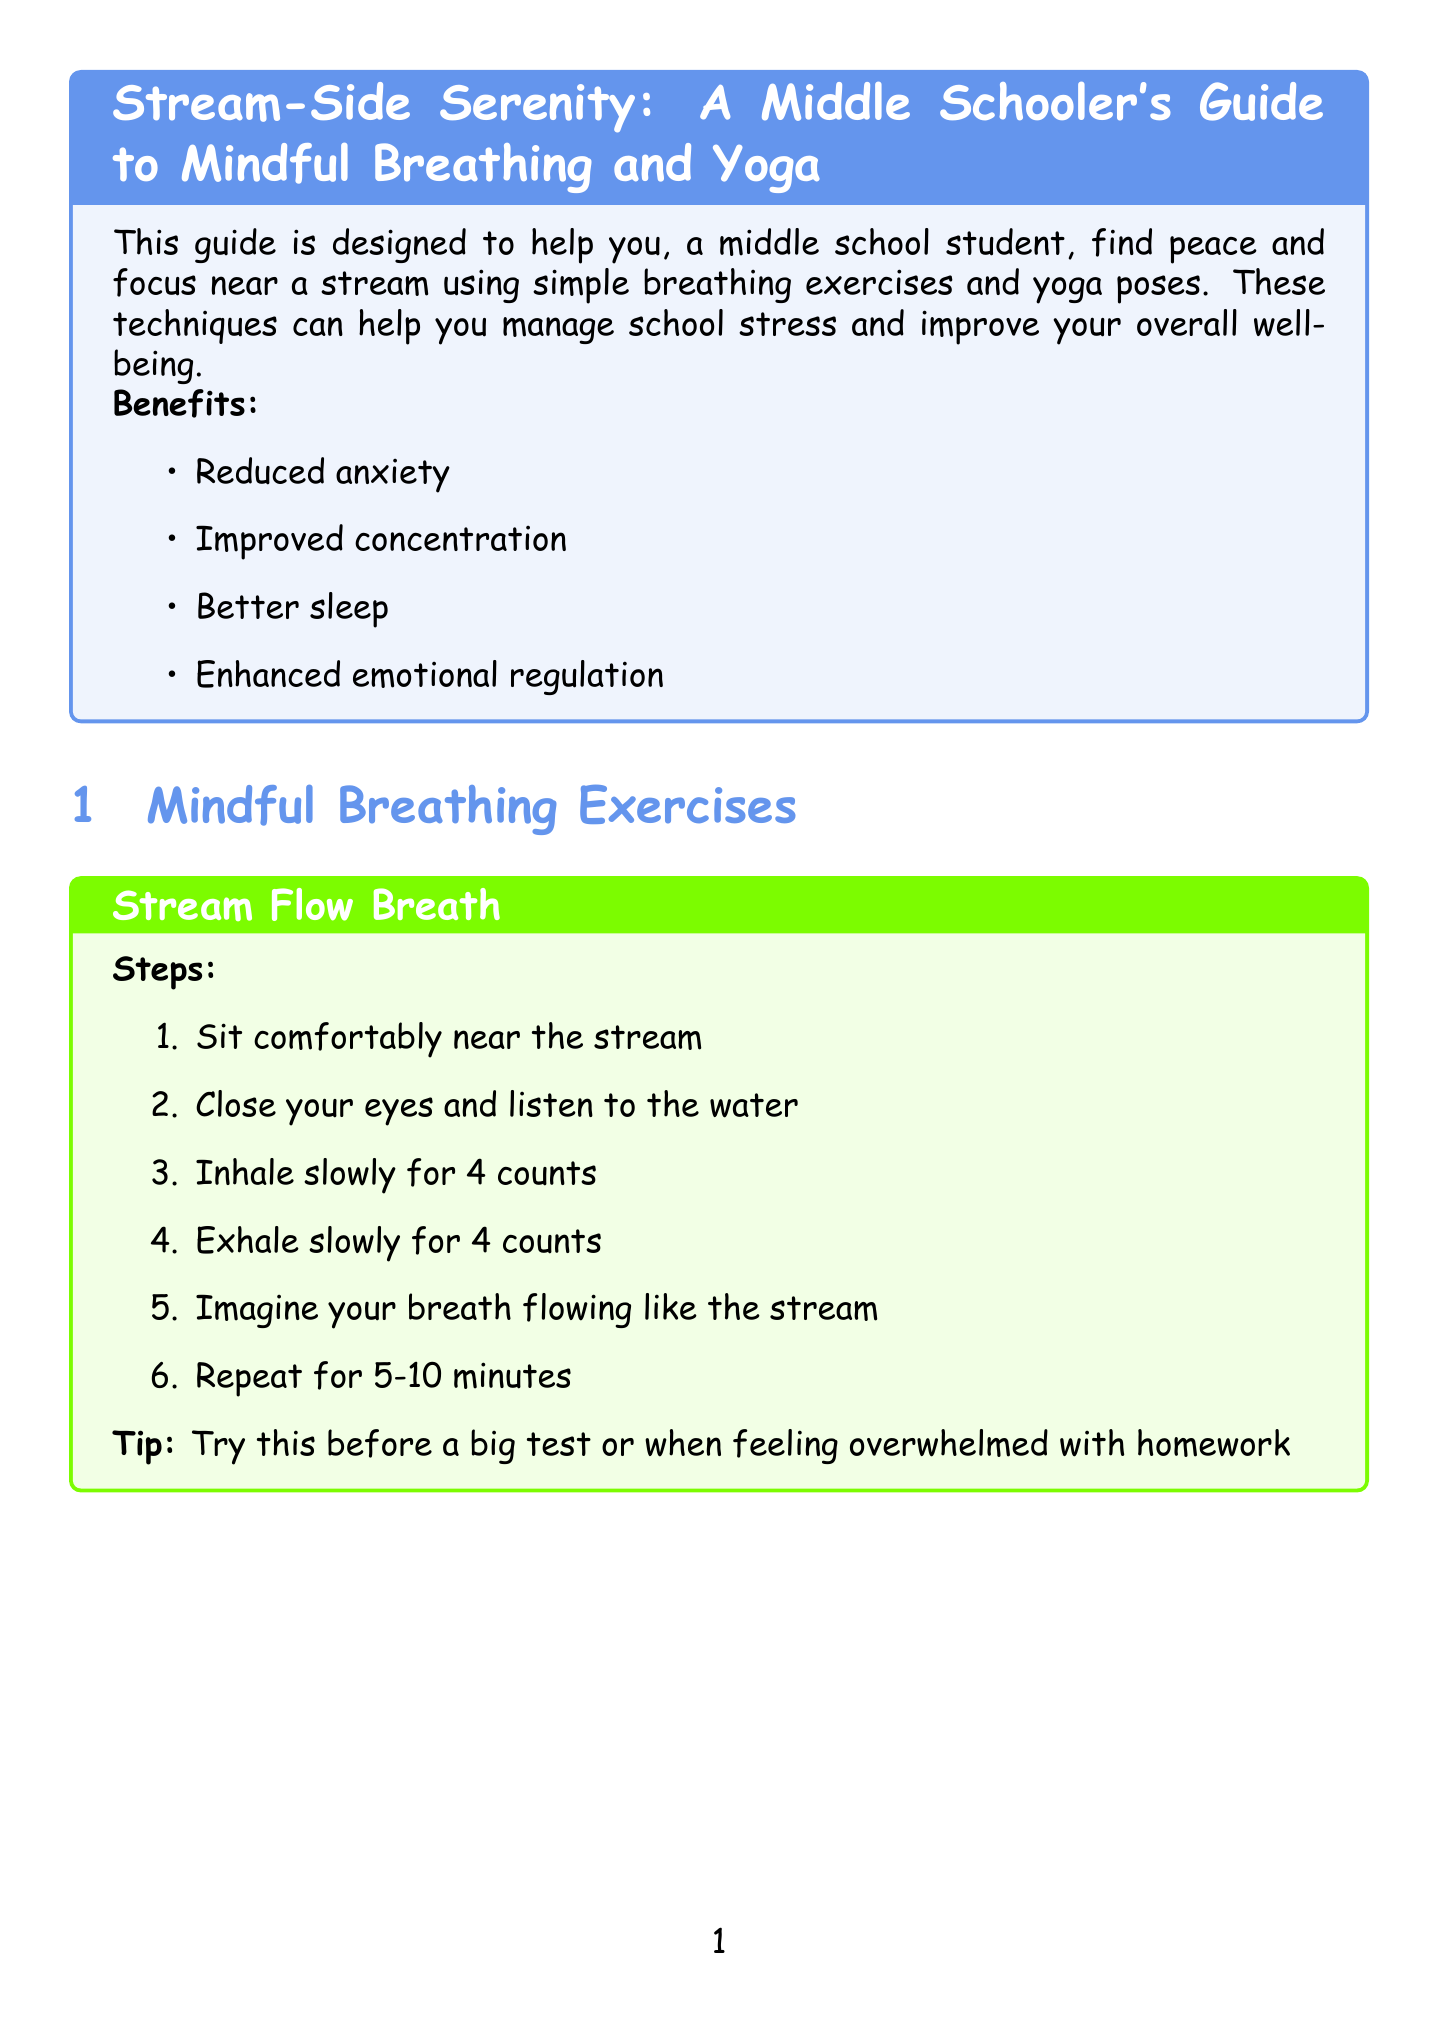What are the benefits of mindful breathing and yoga? The benefits include reduced anxiety, improved concentration, better sleep, and enhanced emotional regulation.
Answer: Reduced anxiety, improved concentration, better sleep, enhanced emotional regulation How long should you hold Tree Pose? The document specifies holding Tree Pose for 30 seconds on each side.
Answer: 30 seconds What should you do during Stream Flow Breath? During Stream Flow Breath, you should inhale slowly for 4 counts and exhale slowly for 4 counts.
Answer: Inhale slowly for 4 counts, exhale slowly for 4 counts What is recommended to practice before a big test? The recommended practice before a big test is Stream Flow Breath.
Answer: Stream Flow Breath In which pose should you kneel on a soft patch of grass? The pose to kneel on a soft patch of grass is Child's Pose.
Answer: Child's Pose What is the duration for Pebble Counting Breath? The document suggests practicing Pebble Counting Breath for 5-10 minutes.
Answer: 5-10 minutes What type of clothing should you wear while practicing? The document advises wearing comfortable clothing that allows easy movement.
Answer: Comfortable clothing What should you do if you feel dizzy or uncomfortable? If you feel dizzy or uncomfortable, the document advises to stop and rest.
Answer: Stop and rest 